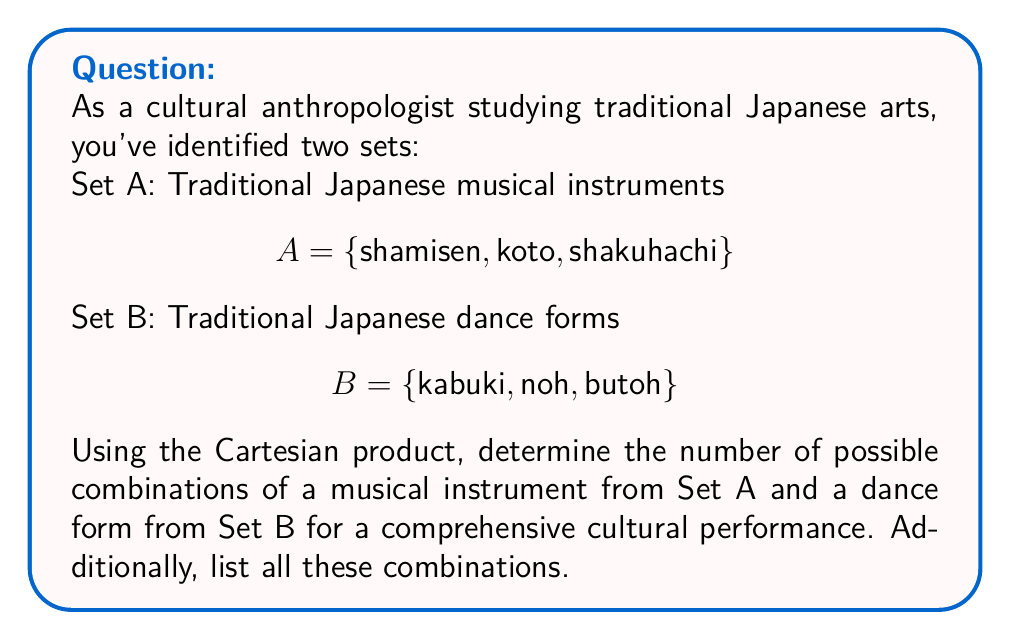Teach me how to tackle this problem. To solve this problem, we'll use the concept of Cartesian product and follow these steps:

1. Recall the definition of Cartesian product:
   The Cartesian product of two sets A and B, denoted as $A \times B$, is the set of all ordered pairs (a, b) where a ∈ A and b ∈ B.

2. Count the elements in each set:
   $|A| = 3$ (shamisen, koto, shakuhachi)
   $|B| = 3$ (kabuki, noh, butoh)

3. Calculate the number of combinations:
   The number of elements in the Cartesian product is given by:
   $|A \times B| = |A| \times |B| = 3 \times 3 = 9$

4. List all combinations:
   $A \times B = \{$
   (shamisen, kabuki), (shamisen, noh), (shamisen, butoh),
   (koto, kabuki), (koto, noh), (koto, butoh),
   (shakuhachi, kabuki), (shakuhachi, noh), (shakuhachi, butoh)
   $\}$

Therefore, there are 9 possible combinations, and we have listed all of them.
Answer: 9 combinations; $\{(\text{shamisen}, \text{kabuki}), (\text{shamisen}, \text{noh}), (\text{shamisen}, \text{butoh}), (\text{koto}, \text{kabuki}), (\text{koto}, \text{noh}), (\text{koto}, \text{butoh}), (\text{shakuhachi}, \text{kabuki}), (\text{shakuhachi}, \text{noh}), (\text{shakuhachi}, \text{butoh})\}$ 